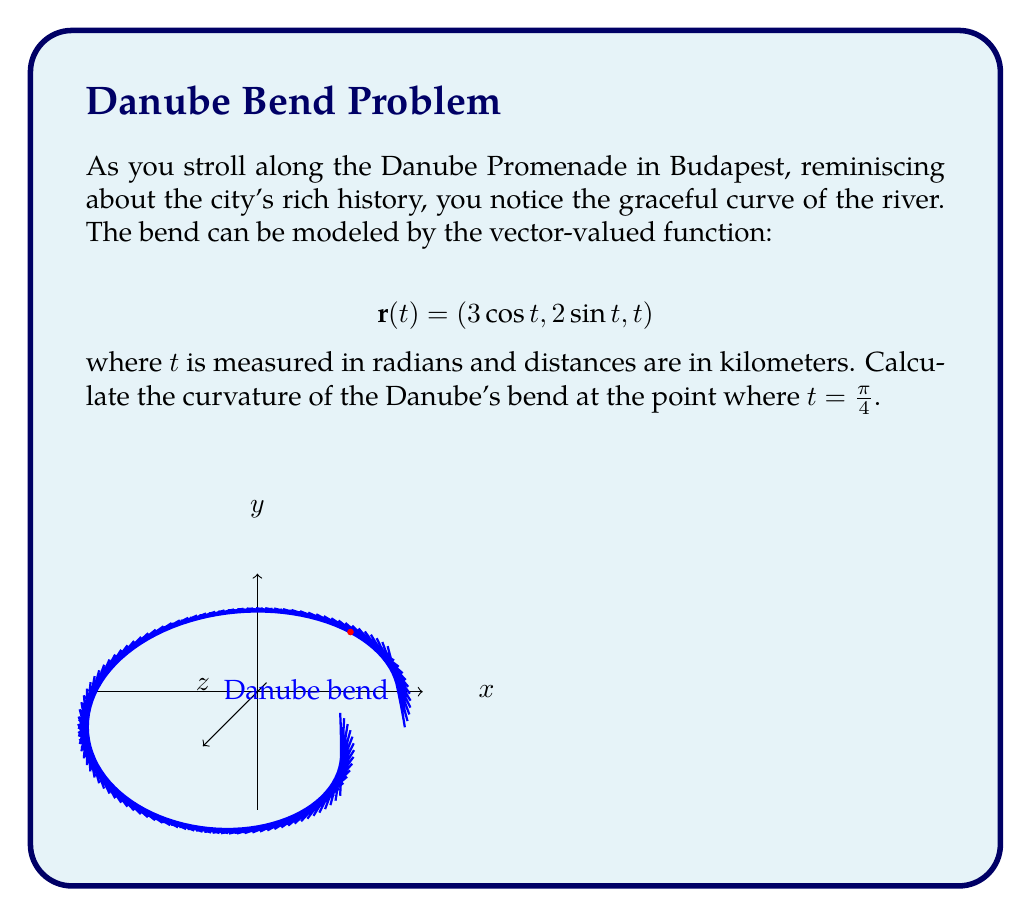Help me with this question. To calculate the curvature, we'll follow these steps:

1) First, we need to find $\mathbf{r}'(t)$ and $\mathbf{r}''(t)$:

   $$\mathbf{r}'(t) = (-3\sin t, 2\cos t, 1)$$
   $$\mathbf{r}''(t) = (-3\cos t, -2\sin t, 0)$$

2) The curvature formula is:

   $$\kappa = \frac{|\mathbf{r}'(t) \times \mathbf{r}''(t)|}{|\mathbf{r}'(t)|^3}$$

3) Let's calculate $\mathbf{r}'(t) \times \mathbf{r}''(t)$:

   $$\begin{vmatrix} 
   \mathbf{i} & \mathbf{j} & \mathbf{k} \\
   -3\sin t & 2\cos t & 1 \\
   -3\cos t & -2\sin t & 0
   \end{vmatrix}$$

   $= (-2\sin t - 3\cos t)\mathbf{i} + (-3\sin t + 3\cos t)\mathbf{j} + (-6\sin^2 t - 6\cos^2 t)\mathbf{k}$

4) At $t = \frac{\pi}{4}$:

   $\mathbf{r}'(\frac{\pi}{4}) = (-\frac{3}{\sqrt{2}}, \frac{2}{\sqrt{2}}, 1)$
   
   $\mathbf{r}''(\frac{\pi}{4}) = (-\frac{3}{\sqrt{2}}, -\frac{2}{\sqrt{2}}, 0)$
   
   $\mathbf{r}'(\frac{\pi}{4}) \times \mathbf{r}''(\frac{\pi}{4}) = (-\frac{5}{\sqrt{2}}, -\frac{5}{\sqrt{2}}, -6)$

5) Calculate magnitudes:

   $|\mathbf{r}'(\frac{\pi}{4}) \times \mathbf{r}''(\frac{\pi}{4})| = \sqrt{(\frac{5}{\sqrt{2}})^2 + (\frac{5}{\sqrt{2}})^2 + 6^2} = \sqrt{25 + 36} = \sqrt{61}$
   
   $|\mathbf{r}'(\frac{\pi}{4})|^3 = ((\frac{3}{\sqrt{2}})^2 + (\frac{2}{\sqrt{2}})^2 + 1^2)^{3/2} = (\frac{13}{2})^{3/2}$

6) Finally, calculate curvature:

   $$\kappa = \frac{\sqrt{61}}{(\frac{13}{2})^{3/2}}$$
Answer: $\kappa = \frac{\sqrt{61}}{(\frac{13}{2})^{3/2}}$ km$^{-1}$ 